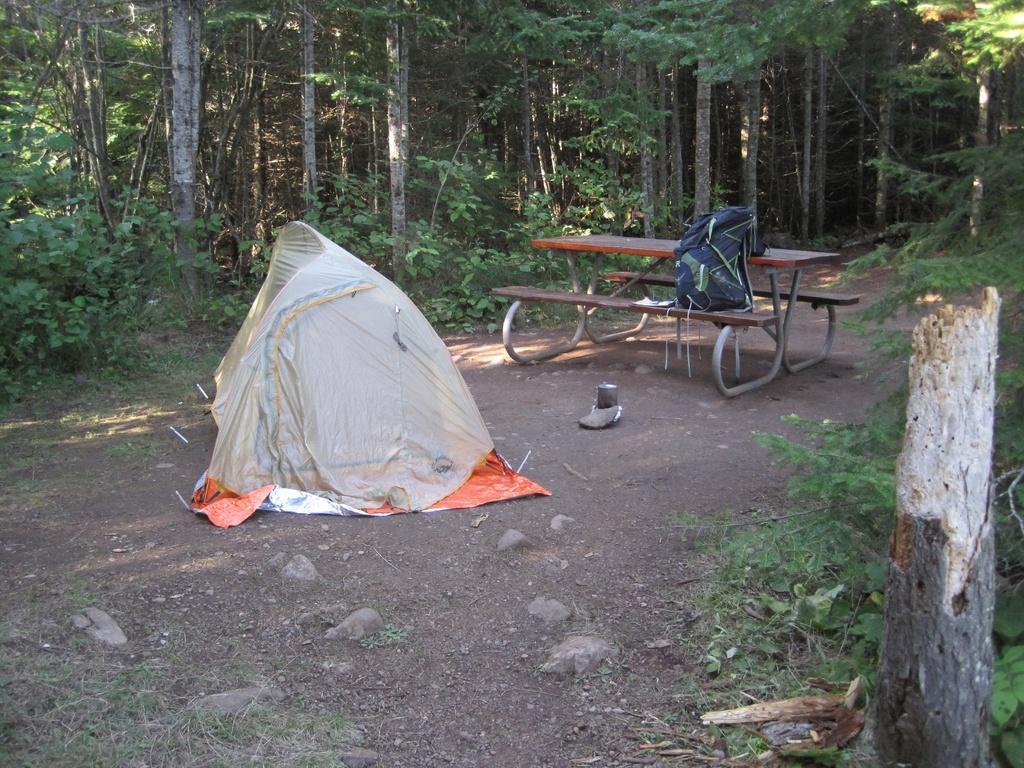Please provide a concise description of this image. In this image we can see a tent and a bench in the middle of the forest, on the other side of the text there are trees. 